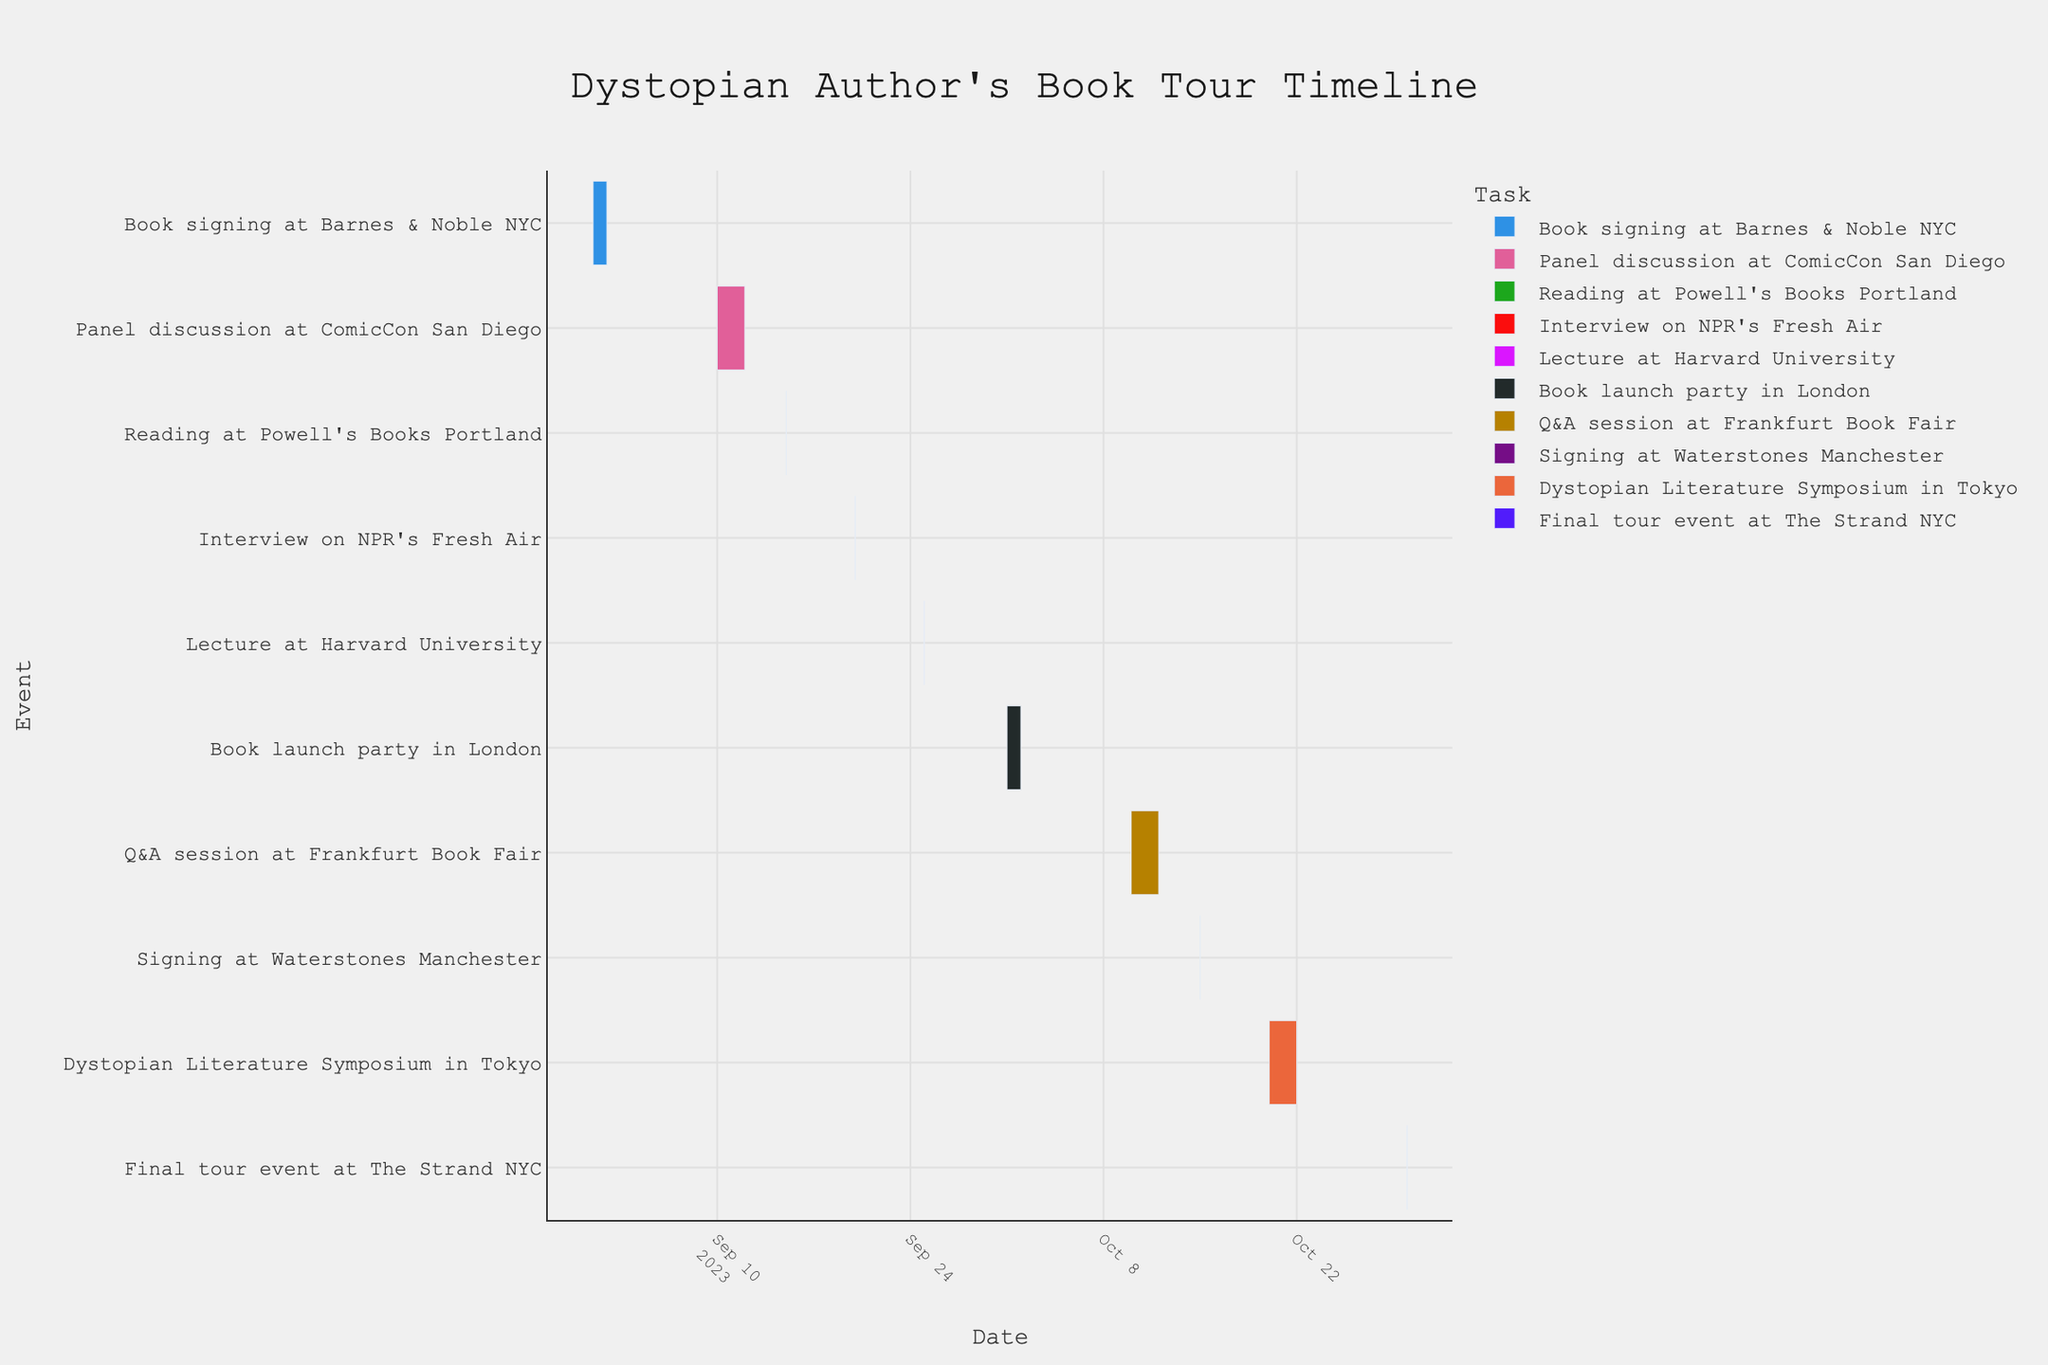What is the title of the figure? The title is usually at the top center of the chart. In this figure, the title is "Dystopian Author's Book Tour Timeline".
Answer: "Dystopian Author's Book Tour Timeline" How many events take place in September? From the Gantt chart, count the number of tasks that start or end within September. There are 5 events: Book signing at Barnes & Noble NYC, Panel discussion at ComicCon San Diego, Reading at Powell's Books Portland, Interview on NPR's Fresh Air, and Lecture at Harvard University.
Answer: 5 Which event has the longest duration? By comparing the start and end dates for each event, the Panel discussion at ComicCon San Diego and the Q&A session at Frankfurt Book Fair both last 3 days each.
Answer: Panel discussion at ComicCon San Diego; Q&A session at Frankfurt Book Fair How many single-day events are there? Examine the Gantt chart for events where the start and end dates are identical. There are 5 single-day events.
Answer: 5 Are there any events in the timeline that occur at the same time? Check for overlapping events in the timeline. There are no overlapping events in the Gantt chart.
Answer: No Which event marks the end of the book tour? The last event on the timeline is the final event. According to the chart, the final tour event at The Strand NYC marks the end of the tour.
Answer: Final tour event at The Strand NYC Which event directly follows the Lecture at Harvard University? Look for the event immediately after the Lecture at Harvard University on the timeline. The next event is the Book launch party in London.
Answer: Book launch party in London How many events are held outside the United States? Identify the events that take place in locations outside the United States. There are 4: Book launch party in London, Q&A session at Frankfurt Book Fair, Signing at Waterstones Manchester, and Dystopian Literature Symposium in Tokyo.
Answer: 4 What is the duration between the first and the last event? Calculate the difference in days between the start date of the first event (September 1) and the end date of the last event (October 30).
Answer: 59 days Between the Panel discussion at ComicCon San Diego and the Reading at Powell’s Books Portland, which event starts earlier and which one ends later? The Panel discussion at ComicCon San Diego starts on September 10 and ends on September 12, while the Reading at Powell’s Books Portland is on September 15. Therefore, the Panel discussion starts earlier, and the Reading at Powell’s Books Portland ends later.
Answer: The Panel discussion starts earlier; The Reading ends later 